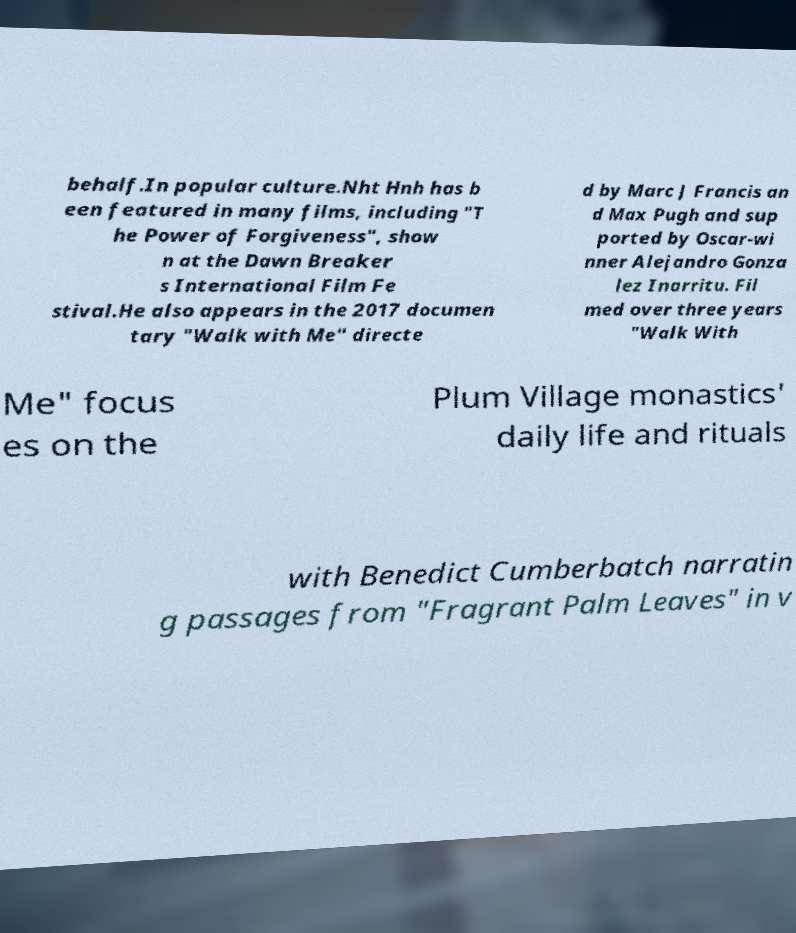For documentation purposes, I need the text within this image transcribed. Could you provide that? behalf.In popular culture.Nht Hnh has b een featured in many films, including "T he Power of Forgiveness", show n at the Dawn Breaker s International Film Fe stival.He also appears in the 2017 documen tary "Walk with Me" directe d by Marc J Francis an d Max Pugh and sup ported by Oscar-wi nner Alejandro Gonza lez Inarritu. Fil med over three years "Walk With Me" focus es on the Plum Village monastics' daily life and rituals with Benedict Cumberbatch narratin g passages from "Fragrant Palm Leaves" in v 